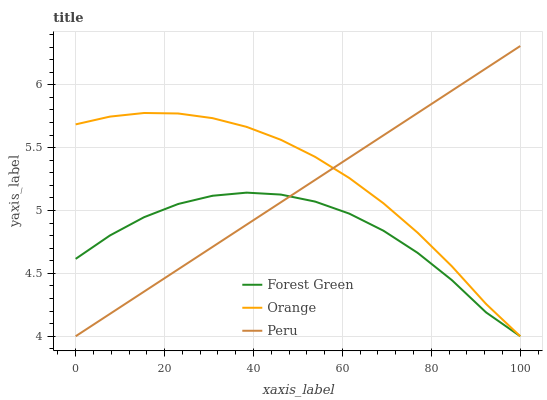Does Forest Green have the minimum area under the curve?
Answer yes or no. Yes. Does Orange have the maximum area under the curve?
Answer yes or no. Yes. Does Peru have the minimum area under the curve?
Answer yes or no. No. Does Peru have the maximum area under the curve?
Answer yes or no. No. Is Peru the smoothest?
Answer yes or no. Yes. Is Forest Green the roughest?
Answer yes or no. Yes. Is Forest Green the smoothest?
Answer yes or no. No. Is Peru the roughest?
Answer yes or no. No. Does Orange have the lowest value?
Answer yes or no. Yes. Does Peru have the highest value?
Answer yes or no. Yes. Does Forest Green have the highest value?
Answer yes or no. No. Does Peru intersect Orange?
Answer yes or no. Yes. Is Peru less than Orange?
Answer yes or no. No. Is Peru greater than Orange?
Answer yes or no. No. 